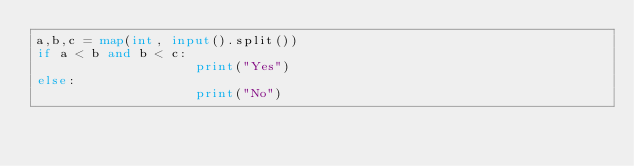Convert code to text. <code><loc_0><loc_0><loc_500><loc_500><_Python_>a,b,c = map(int, input().split())
if a < b and b < c:
                    print("Yes")
else:
                    print("No")</code> 